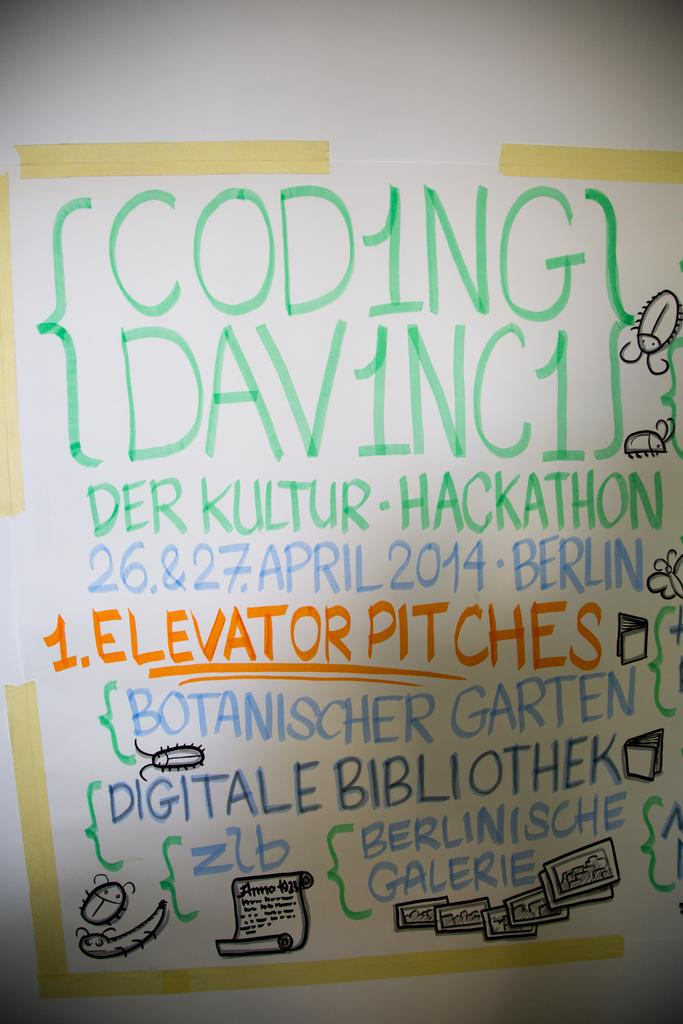<image>
Write a terse but informative summary of the picture. A coding board with elevator pitches and the date April 2014 written. 